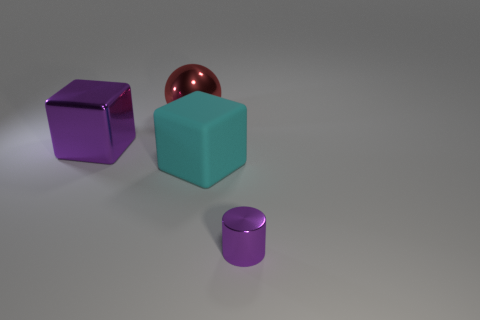Add 3 cubes. How many objects exist? 7 Subtract all cylinders. How many objects are left? 3 Subtract all red balls. Subtract all cyan matte cubes. How many objects are left? 2 Add 2 large shiny cubes. How many large shiny cubes are left? 3 Add 1 tiny cyan spheres. How many tiny cyan spheres exist? 1 Subtract 1 purple cubes. How many objects are left? 3 Subtract all green cubes. Subtract all red balls. How many cubes are left? 2 